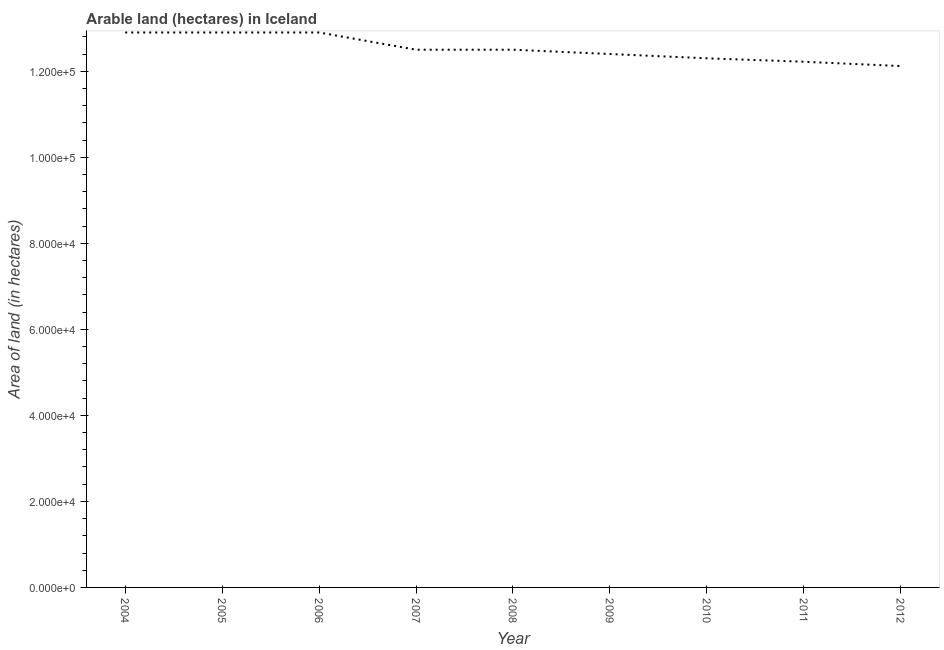What is the area of land in 2006?
Your answer should be compact. 1.29e+05. Across all years, what is the maximum area of land?
Your answer should be very brief. 1.29e+05. Across all years, what is the minimum area of land?
Offer a very short reply. 1.21e+05. In which year was the area of land maximum?
Your response must be concise. 2004. What is the sum of the area of land?
Offer a terse response. 1.13e+06. What is the difference between the area of land in 2004 and 2011?
Provide a succinct answer. 6800. What is the average area of land per year?
Offer a terse response. 1.25e+05. What is the median area of land?
Offer a terse response. 1.25e+05. Do a majority of the years between 2010 and 2004 (inclusive) have area of land greater than 24000 hectares?
Your answer should be very brief. Yes. What is the ratio of the area of land in 2007 to that in 2012?
Give a very brief answer. 1.03. What is the difference between the highest and the second highest area of land?
Ensure brevity in your answer.  0. Is the sum of the area of land in 2009 and 2012 greater than the maximum area of land across all years?
Offer a very short reply. Yes. What is the difference between the highest and the lowest area of land?
Offer a terse response. 7800. How many years are there in the graph?
Make the answer very short. 9. Are the values on the major ticks of Y-axis written in scientific E-notation?
Give a very brief answer. Yes. Does the graph contain grids?
Give a very brief answer. No. What is the title of the graph?
Provide a short and direct response. Arable land (hectares) in Iceland. What is the label or title of the Y-axis?
Your response must be concise. Area of land (in hectares). What is the Area of land (in hectares) of 2004?
Provide a short and direct response. 1.29e+05. What is the Area of land (in hectares) of 2005?
Ensure brevity in your answer.  1.29e+05. What is the Area of land (in hectares) in 2006?
Your response must be concise. 1.29e+05. What is the Area of land (in hectares) in 2007?
Give a very brief answer. 1.25e+05. What is the Area of land (in hectares) in 2008?
Offer a terse response. 1.25e+05. What is the Area of land (in hectares) of 2009?
Provide a succinct answer. 1.24e+05. What is the Area of land (in hectares) of 2010?
Ensure brevity in your answer.  1.23e+05. What is the Area of land (in hectares) of 2011?
Provide a succinct answer. 1.22e+05. What is the Area of land (in hectares) in 2012?
Your answer should be very brief. 1.21e+05. What is the difference between the Area of land (in hectares) in 2004 and 2005?
Keep it short and to the point. 0. What is the difference between the Area of land (in hectares) in 2004 and 2007?
Keep it short and to the point. 4000. What is the difference between the Area of land (in hectares) in 2004 and 2008?
Ensure brevity in your answer.  4000. What is the difference between the Area of land (in hectares) in 2004 and 2010?
Provide a succinct answer. 6000. What is the difference between the Area of land (in hectares) in 2004 and 2011?
Give a very brief answer. 6800. What is the difference between the Area of land (in hectares) in 2004 and 2012?
Keep it short and to the point. 7800. What is the difference between the Area of land (in hectares) in 2005 and 2007?
Keep it short and to the point. 4000. What is the difference between the Area of land (in hectares) in 2005 and 2008?
Give a very brief answer. 4000. What is the difference between the Area of land (in hectares) in 2005 and 2009?
Provide a short and direct response. 5000. What is the difference between the Area of land (in hectares) in 2005 and 2010?
Make the answer very short. 6000. What is the difference between the Area of land (in hectares) in 2005 and 2011?
Ensure brevity in your answer.  6800. What is the difference between the Area of land (in hectares) in 2005 and 2012?
Make the answer very short. 7800. What is the difference between the Area of land (in hectares) in 2006 and 2007?
Your answer should be very brief. 4000. What is the difference between the Area of land (in hectares) in 2006 and 2008?
Make the answer very short. 4000. What is the difference between the Area of land (in hectares) in 2006 and 2010?
Give a very brief answer. 6000. What is the difference between the Area of land (in hectares) in 2006 and 2011?
Offer a very short reply. 6800. What is the difference between the Area of land (in hectares) in 2006 and 2012?
Keep it short and to the point. 7800. What is the difference between the Area of land (in hectares) in 2007 and 2008?
Give a very brief answer. 0. What is the difference between the Area of land (in hectares) in 2007 and 2009?
Offer a terse response. 1000. What is the difference between the Area of land (in hectares) in 2007 and 2011?
Your response must be concise. 2800. What is the difference between the Area of land (in hectares) in 2007 and 2012?
Your response must be concise. 3800. What is the difference between the Area of land (in hectares) in 2008 and 2009?
Give a very brief answer. 1000. What is the difference between the Area of land (in hectares) in 2008 and 2011?
Your response must be concise. 2800. What is the difference between the Area of land (in hectares) in 2008 and 2012?
Your response must be concise. 3800. What is the difference between the Area of land (in hectares) in 2009 and 2011?
Offer a very short reply. 1800. What is the difference between the Area of land (in hectares) in 2009 and 2012?
Make the answer very short. 2800. What is the difference between the Area of land (in hectares) in 2010 and 2011?
Offer a very short reply. 800. What is the difference between the Area of land (in hectares) in 2010 and 2012?
Provide a short and direct response. 1800. What is the difference between the Area of land (in hectares) in 2011 and 2012?
Keep it short and to the point. 1000. What is the ratio of the Area of land (in hectares) in 2004 to that in 2006?
Offer a terse response. 1. What is the ratio of the Area of land (in hectares) in 2004 to that in 2007?
Offer a terse response. 1.03. What is the ratio of the Area of land (in hectares) in 2004 to that in 2008?
Offer a terse response. 1.03. What is the ratio of the Area of land (in hectares) in 2004 to that in 2010?
Your answer should be compact. 1.05. What is the ratio of the Area of land (in hectares) in 2004 to that in 2011?
Your answer should be very brief. 1.06. What is the ratio of the Area of land (in hectares) in 2004 to that in 2012?
Your answer should be very brief. 1.06. What is the ratio of the Area of land (in hectares) in 2005 to that in 2006?
Offer a terse response. 1. What is the ratio of the Area of land (in hectares) in 2005 to that in 2007?
Make the answer very short. 1.03. What is the ratio of the Area of land (in hectares) in 2005 to that in 2008?
Offer a terse response. 1.03. What is the ratio of the Area of land (in hectares) in 2005 to that in 2009?
Keep it short and to the point. 1.04. What is the ratio of the Area of land (in hectares) in 2005 to that in 2010?
Give a very brief answer. 1.05. What is the ratio of the Area of land (in hectares) in 2005 to that in 2011?
Your answer should be very brief. 1.06. What is the ratio of the Area of land (in hectares) in 2005 to that in 2012?
Your response must be concise. 1.06. What is the ratio of the Area of land (in hectares) in 2006 to that in 2007?
Your response must be concise. 1.03. What is the ratio of the Area of land (in hectares) in 2006 to that in 2008?
Keep it short and to the point. 1.03. What is the ratio of the Area of land (in hectares) in 2006 to that in 2010?
Give a very brief answer. 1.05. What is the ratio of the Area of land (in hectares) in 2006 to that in 2011?
Your response must be concise. 1.06. What is the ratio of the Area of land (in hectares) in 2006 to that in 2012?
Keep it short and to the point. 1.06. What is the ratio of the Area of land (in hectares) in 2007 to that in 2008?
Give a very brief answer. 1. What is the ratio of the Area of land (in hectares) in 2007 to that in 2010?
Offer a terse response. 1.02. What is the ratio of the Area of land (in hectares) in 2007 to that in 2011?
Make the answer very short. 1.02. What is the ratio of the Area of land (in hectares) in 2007 to that in 2012?
Offer a terse response. 1.03. What is the ratio of the Area of land (in hectares) in 2008 to that in 2009?
Your answer should be very brief. 1.01. What is the ratio of the Area of land (in hectares) in 2008 to that in 2011?
Make the answer very short. 1.02. What is the ratio of the Area of land (in hectares) in 2008 to that in 2012?
Your answer should be very brief. 1.03. What is the ratio of the Area of land (in hectares) in 2009 to that in 2011?
Make the answer very short. 1.01. What is the ratio of the Area of land (in hectares) in 2009 to that in 2012?
Ensure brevity in your answer.  1.02. What is the ratio of the Area of land (in hectares) in 2010 to that in 2012?
Provide a succinct answer. 1.01. 